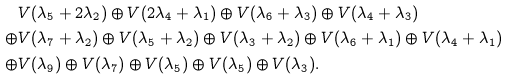<formula> <loc_0><loc_0><loc_500><loc_500>& V ( \lambda _ { 5 } + 2 \lambda _ { 2 } ) \oplus V ( 2 \lambda _ { 4 } + \lambda _ { 1 } ) \oplus V ( \lambda _ { 6 } + \lambda _ { 3 } ) \oplus V ( \lambda _ { 4 } + \lambda _ { 3 } ) \\ \oplus & V ( \lambda _ { 7 } + \lambda _ { 2 } ) \oplus V ( \lambda _ { 5 } + \lambda _ { 2 } ) \oplus V ( \lambda _ { 3 } + \lambda _ { 2 } ) \oplus V ( \lambda _ { 6 } + \lambda _ { 1 } ) \oplus V ( \lambda _ { 4 } + \lambda _ { 1 } ) \\ \oplus & V ( \lambda _ { 9 } ) \oplus V ( \lambda _ { 7 } ) \oplus V ( \lambda _ { 5 } ) \oplus V ( \lambda _ { 5 } ) \oplus V ( \lambda _ { 3 } ) .</formula> 